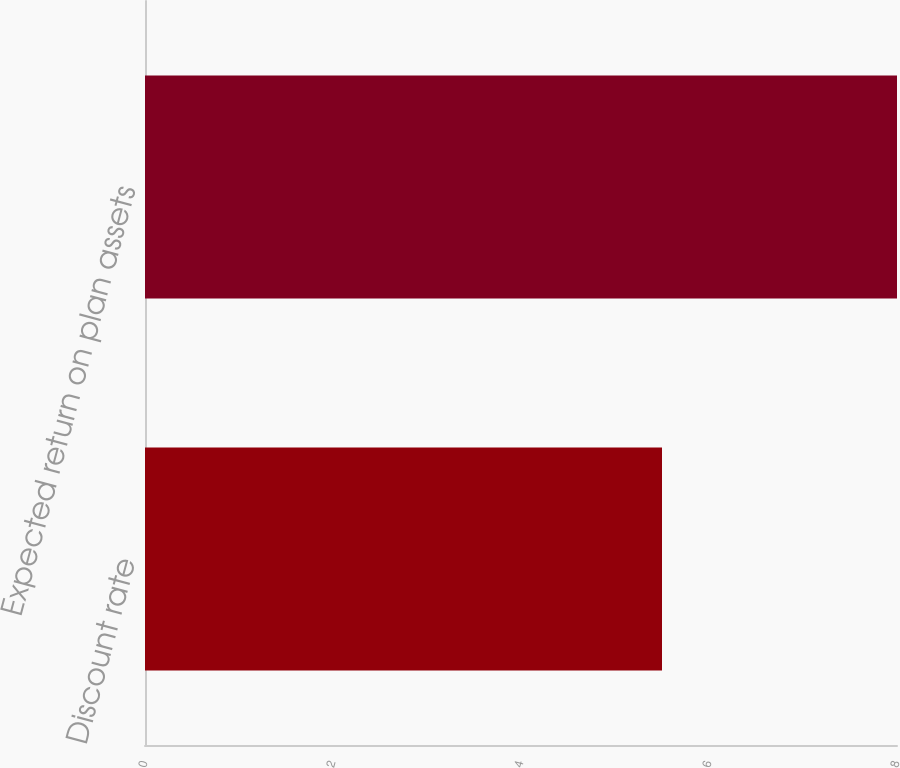Convert chart. <chart><loc_0><loc_0><loc_500><loc_500><bar_chart><fcel>Discount rate<fcel>Expected return on plan assets<nl><fcel>5.5<fcel>8<nl></chart> 